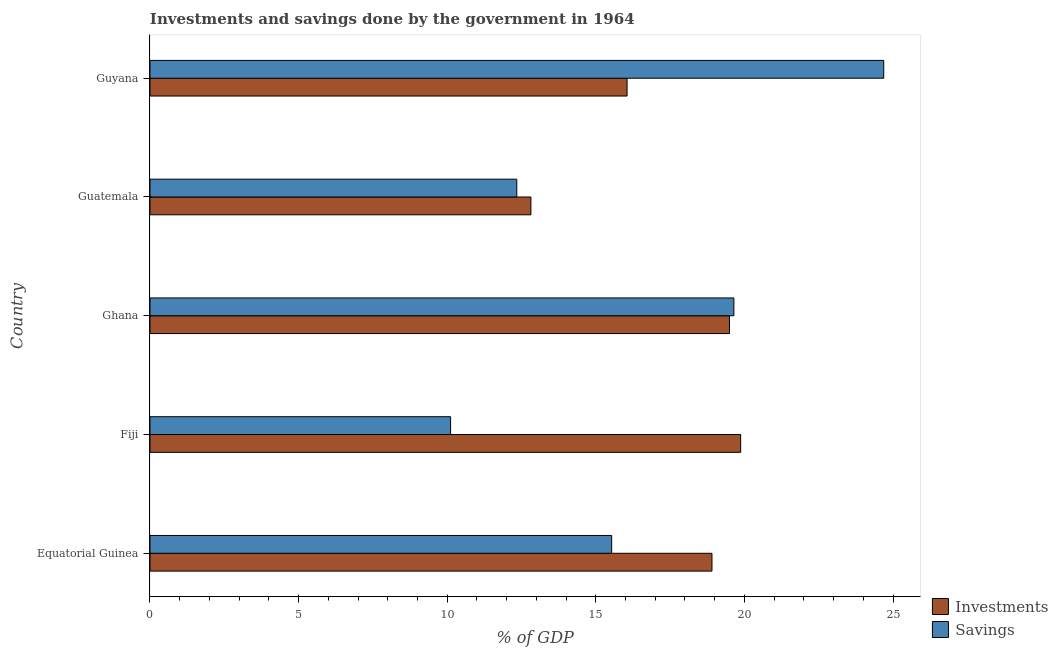How many different coloured bars are there?
Provide a short and direct response. 2. How many bars are there on the 2nd tick from the bottom?
Provide a short and direct response. 2. In how many cases, is the number of bars for a given country not equal to the number of legend labels?
Offer a terse response. 0. What is the investments of government in Guyana?
Your answer should be compact. 16.05. Across all countries, what is the maximum investments of government?
Your answer should be very brief. 19.87. Across all countries, what is the minimum savings of government?
Your response must be concise. 10.11. In which country was the savings of government maximum?
Offer a terse response. Guyana. In which country was the savings of government minimum?
Give a very brief answer. Fiji. What is the total savings of government in the graph?
Provide a succinct answer. 82.32. What is the difference between the investments of government in Fiji and that in Guyana?
Offer a very short reply. 3.82. What is the difference between the investments of government in Equatorial Guinea and the savings of government in Ghana?
Offer a terse response. -0.74. What is the average savings of government per country?
Ensure brevity in your answer.  16.46. What is the difference between the savings of government and investments of government in Guatemala?
Make the answer very short. -0.47. What is the ratio of the savings of government in Equatorial Guinea to that in Fiji?
Keep it short and to the point. 1.54. Is the investments of government in Fiji less than that in Guatemala?
Keep it short and to the point. No. Is the difference between the savings of government in Ghana and Guatemala greater than the difference between the investments of government in Ghana and Guatemala?
Your response must be concise. Yes. What is the difference between the highest and the second highest investments of government?
Keep it short and to the point. 0.38. What is the difference between the highest and the lowest investments of government?
Provide a short and direct response. 7.06. What does the 2nd bar from the top in Ghana represents?
Provide a succinct answer. Investments. What does the 1st bar from the bottom in Equatorial Guinea represents?
Keep it short and to the point. Investments. Are all the bars in the graph horizontal?
Your answer should be compact. Yes. What is the difference between two consecutive major ticks on the X-axis?
Make the answer very short. 5. Does the graph contain any zero values?
Ensure brevity in your answer.  No. Does the graph contain grids?
Offer a very short reply. No. Where does the legend appear in the graph?
Your answer should be very brief. Bottom right. How many legend labels are there?
Provide a short and direct response. 2. How are the legend labels stacked?
Make the answer very short. Vertical. What is the title of the graph?
Provide a succinct answer. Investments and savings done by the government in 1964. Does "Manufacturing industries and construction" appear as one of the legend labels in the graph?
Provide a short and direct response. No. What is the label or title of the X-axis?
Ensure brevity in your answer.  % of GDP. What is the % of GDP of Investments in Equatorial Guinea?
Offer a very short reply. 18.91. What is the % of GDP in Savings in Equatorial Guinea?
Provide a short and direct response. 15.53. What is the % of GDP of Investments in Fiji?
Your answer should be very brief. 19.87. What is the % of GDP in Savings in Fiji?
Make the answer very short. 10.11. What is the % of GDP in Investments in Ghana?
Keep it short and to the point. 19.5. What is the % of GDP of Savings in Ghana?
Give a very brief answer. 19.65. What is the % of GDP of Investments in Guatemala?
Offer a very short reply. 12.82. What is the % of GDP in Savings in Guatemala?
Give a very brief answer. 12.34. What is the % of GDP of Investments in Guyana?
Your answer should be very brief. 16.05. What is the % of GDP of Savings in Guyana?
Provide a succinct answer. 24.69. Across all countries, what is the maximum % of GDP of Investments?
Your answer should be compact. 19.87. Across all countries, what is the maximum % of GDP of Savings?
Ensure brevity in your answer.  24.69. Across all countries, what is the minimum % of GDP of Investments?
Your response must be concise. 12.82. Across all countries, what is the minimum % of GDP in Savings?
Keep it short and to the point. 10.11. What is the total % of GDP of Investments in the graph?
Ensure brevity in your answer.  87.15. What is the total % of GDP in Savings in the graph?
Ensure brevity in your answer.  82.32. What is the difference between the % of GDP of Investments in Equatorial Guinea and that in Fiji?
Your answer should be compact. -0.96. What is the difference between the % of GDP in Savings in Equatorial Guinea and that in Fiji?
Your response must be concise. 5.42. What is the difference between the % of GDP of Investments in Equatorial Guinea and that in Ghana?
Provide a succinct answer. -0.59. What is the difference between the % of GDP of Savings in Equatorial Guinea and that in Ghana?
Your answer should be compact. -4.11. What is the difference between the % of GDP of Investments in Equatorial Guinea and that in Guatemala?
Ensure brevity in your answer.  6.09. What is the difference between the % of GDP of Savings in Equatorial Guinea and that in Guatemala?
Offer a very short reply. 3.19. What is the difference between the % of GDP of Investments in Equatorial Guinea and that in Guyana?
Your answer should be compact. 2.86. What is the difference between the % of GDP in Savings in Equatorial Guinea and that in Guyana?
Give a very brief answer. -9.15. What is the difference between the % of GDP of Investments in Fiji and that in Ghana?
Give a very brief answer. 0.38. What is the difference between the % of GDP in Savings in Fiji and that in Ghana?
Your answer should be compact. -9.53. What is the difference between the % of GDP in Investments in Fiji and that in Guatemala?
Your answer should be compact. 7.06. What is the difference between the % of GDP in Savings in Fiji and that in Guatemala?
Make the answer very short. -2.23. What is the difference between the % of GDP in Investments in Fiji and that in Guyana?
Provide a succinct answer. 3.82. What is the difference between the % of GDP of Savings in Fiji and that in Guyana?
Give a very brief answer. -14.57. What is the difference between the % of GDP in Investments in Ghana and that in Guatemala?
Your answer should be compact. 6.68. What is the difference between the % of GDP in Savings in Ghana and that in Guatemala?
Keep it short and to the point. 7.31. What is the difference between the % of GDP in Investments in Ghana and that in Guyana?
Your response must be concise. 3.45. What is the difference between the % of GDP of Savings in Ghana and that in Guyana?
Provide a succinct answer. -5.04. What is the difference between the % of GDP in Investments in Guatemala and that in Guyana?
Offer a very short reply. -3.24. What is the difference between the % of GDP of Savings in Guatemala and that in Guyana?
Keep it short and to the point. -12.35. What is the difference between the % of GDP of Investments in Equatorial Guinea and the % of GDP of Savings in Fiji?
Your answer should be compact. 8.79. What is the difference between the % of GDP of Investments in Equatorial Guinea and the % of GDP of Savings in Ghana?
Offer a very short reply. -0.74. What is the difference between the % of GDP of Investments in Equatorial Guinea and the % of GDP of Savings in Guatemala?
Your answer should be compact. 6.57. What is the difference between the % of GDP in Investments in Equatorial Guinea and the % of GDP in Savings in Guyana?
Your answer should be very brief. -5.78. What is the difference between the % of GDP of Investments in Fiji and the % of GDP of Savings in Ghana?
Offer a terse response. 0.23. What is the difference between the % of GDP of Investments in Fiji and the % of GDP of Savings in Guatemala?
Offer a very short reply. 7.53. What is the difference between the % of GDP in Investments in Fiji and the % of GDP in Savings in Guyana?
Provide a succinct answer. -4.81. What is the difference between the % of GDP in Investments in Ghana and the % of GDP in Savings in Guatemala?
Offer a very short reply. 7.16. What is the difference between the % of GDP of Investments in Ghana and the % of GDP of Savings in Guyana?
Your answer should be very brief. -5.19. What is the difference between the % of GDP of Investments in Guatemala and the % of GDP of Savings in Guyana?
Provide a succinct answer. -11.87. What is the average % of GDP of Investments per country?
Make the answer very short. 17.43. What is the average % of GDP in Savings per country?
Your answer should be very brief. 16.46. What is the difference between the % of GDP of Investments and % of GDP of Savings in Equatorial Guinea?
Provide a short and direct response. 3.38. What is the difference between the % of GDP in Investments and % of GDP in Savings in Fiji?
Ensure brevity in your answer.  9.76. What is the difference between the % of GDP in Investments and % of GDP in Savings in Ghana?
Make the answer very short. -0.15. What is the difference between the % of GDP of Investments and % of GDP of Savings in Guatemala?
Offer a very short reply. 0.48. What is the difference between the % of GDP of Investments and % of GDP of Savings in Guyana?
Your answer should be compact. -8.64. What is the ratio of the % of GDP in Investments in Equatorial Guinea to that in Fiji?
Your answer should be compact. 0.95. What is the ratio of the % of GDP of Savings in Equatorial Guinea to that in Fiji?
Give a very brief answer. 1.54. What is the ratio of the % of GDP in Investments in Equatorial Guinea to that in Ghana?
Your answer should be compact. 0.97. What is the ratio of the % of GDP of Savings in Equatorial Guinea to that in Ghana?
Offer a terse response. 0.79. What is the ratio of the % of GDP of Investments in Equatorial Guinea to that in Guatemala?
Keep it short and to the point. 1.48. What is the ratio of the % of GDP in Savings in Equatorial Guinea to that in Guatemala?
Ensure brevity in your answer.  1.26. What is the ratio of the % of GDP in Investments in Equatorial Guinea to that in Guyana?
Your response must be concise. 1.18. What is the ratio of the % of GDP in Savings in Equatorial Guinea to that in Guyana?
Your answer should be very brief. 0.63. What is the ratio of the % of GDP in Investments in Fiji to that in Ghana?
Provide a short and direct response. 1.02. What is the ratio of the % of GDP in Savings in Fiji to that in Ghana?
Ensure brevity in your answer.  0.51. What is the ratio of the % of GDP of Investments in Fiji to that in Guatemala?
Your answer should be very brief. 1.55. What is the ratio of the % of GDP in Savings in Fiji to that in Guatemala?
Offer a terse response. 0.82. What is the ratio of the % of GDP in Investments in Fiji to that in Guyana?
Give a very brief answer. 1.24. What is the ratio of the % of GDP of Savings in Fiji to that in Guyana?
Offer a terse response. 0.41. What is the ratio of the % of GDP of Investments in Ghana to that in Guatemala?
Ensure brevity in your answer.  1.52. What is the ratio of the % of GDP of Savings in Ghana to that in Guatemala?
Offer a very short reply. 1.59. What is the ratio of the % of GDP of Investments in Ghana to that in Guyana?
Provide a succinct answer. 1.21. What is the ratio of the % of GDP of Savings in Ghana to that in Guyana?
Your response must be concise. 0.8. What is the ratio of the % of GDP of Investments in Guatemala to that in Guyana?
Offer a terse response. 0.8. What is the ratio of the % of GDP of Savings in Guatemala to that in Guyana?
Ensure brevity in your answer.  0.5. What is the difference between the highest and the second highest % of GDP of Investments?
Your answer should be compact. 0.38. What is the difference between the highest and the second highest % of GDP in Savings?
Ensure brevity in your answer.  5.04. What is the difference between the highest and the lowest % of GDP of Investments?
Make the answer very short. 7.06. What is the difference between the highest and the lowest % of GDP in Savings?
Make the answer very short. 14.57. 